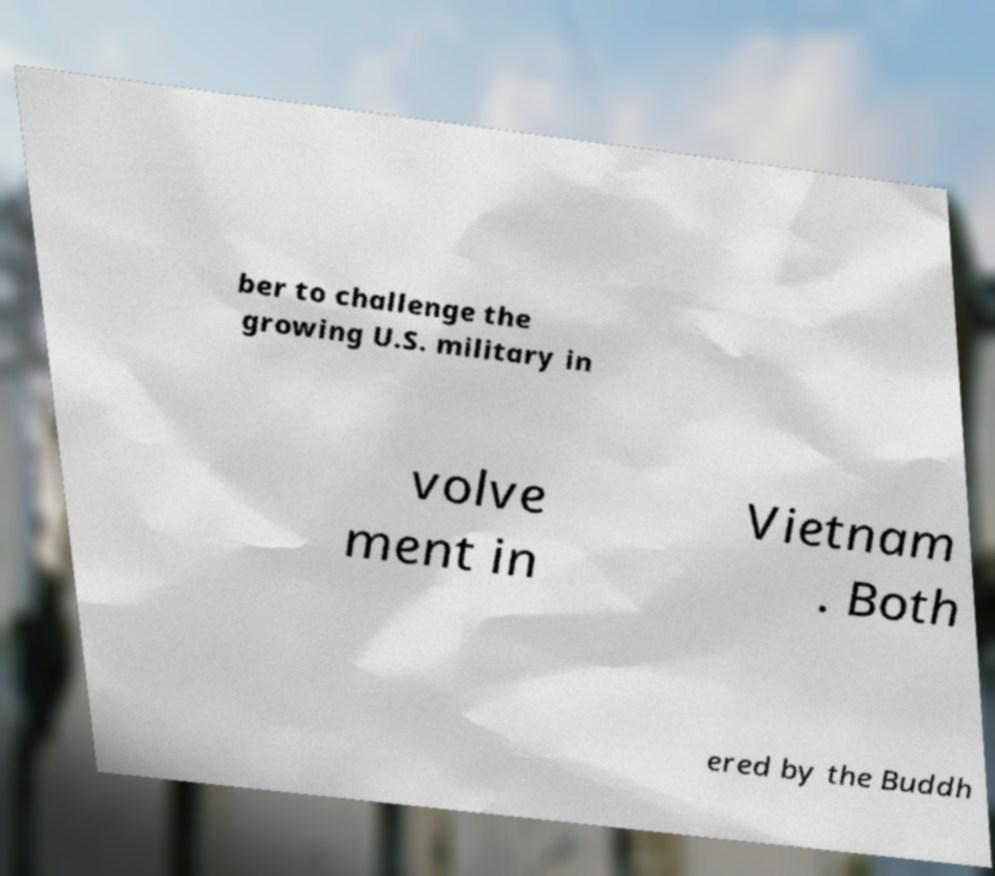What messages or text are displayed in this image? I need them in a readable, typed format. ber to challenge the growing U.S. military in volve ment in Vietnam . Both ered by the Buddh 